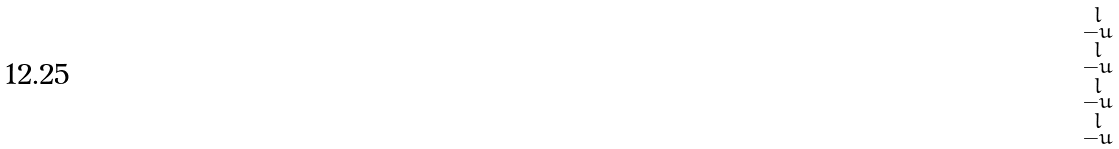<formula> <loc_0><loc_0><loc_500><loc_500>\begin{smallmatrix} l \\ - u \\ l \\ - u \\ l \\ - u \\ l \\ - u \end{smallmatrix}</formula> 